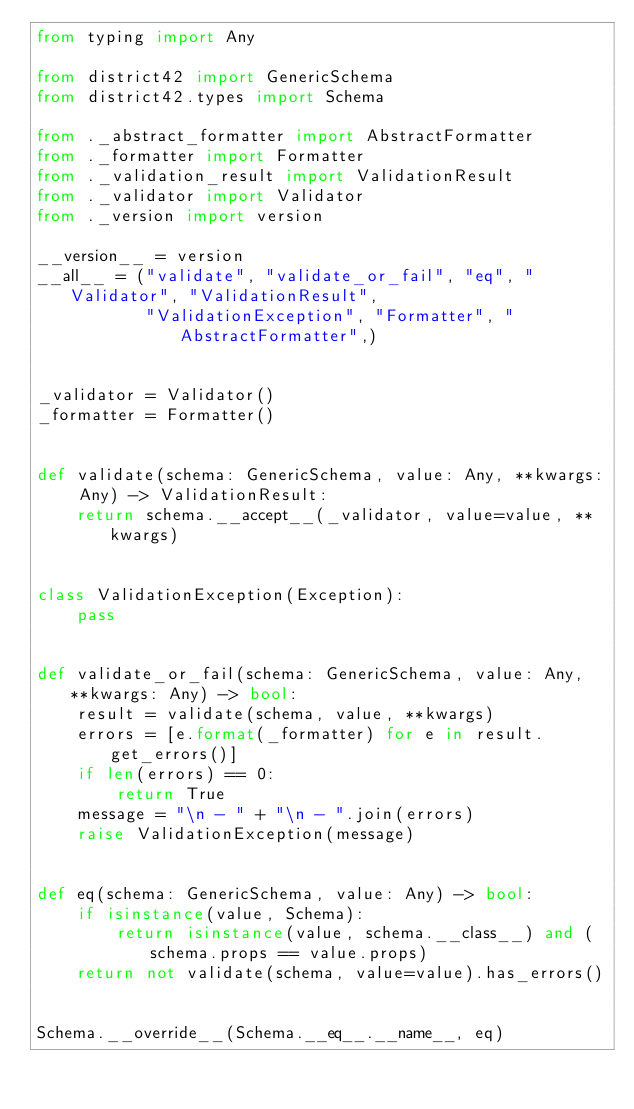<code> <loc_0><loc_0><loc_500><loc_500><_Python_>from typing import Any

from district42 import GenericSchema
from district42.types import Schema

from ._abstract_formatter import AbstractFormatter
from ._formatter import Formatter
from ._validation_result import ValidationResult
from ._validator import Validator
from ._version import version

__version__ = version
__all__ = ("validate", "validate_or_fail", "eq", "Validator", "ValidationResult",
           "ValidationException", "Formatter", "AbstractFormatter",)


_validator = Validator()
_formatter = Formatter()


def validate(schema: GenericSchema, value: Any, **kwargs: Any) -> ValidationResult:
    return schema.__accept__(_validator, value=value, **kwargs)


class ValidationException(Exception):
    pass


def validate_or_fail(schema: GenericSchema, value: Any, **kwargs: Any) -> bool:
    result = validate(schema, value, **kwargs)
    errors = [e.format(_formatter) for e in result.get_errors()]
    if len(errors) == 0:
        return True
    message = "\n - " + "\n - ".join(errors)
    raise ValidationException(message)


def eq(schema: GenericSchema, value: Any) -> bool:
    if isinstance(value, Schema):
        return isinstance(value, schema.__class__) and (schema.props == value.props)
    return not validate(schema, value=value).has_errors()


Schema.__override__(Schema.__eq__.__name__, eq)
</code> 